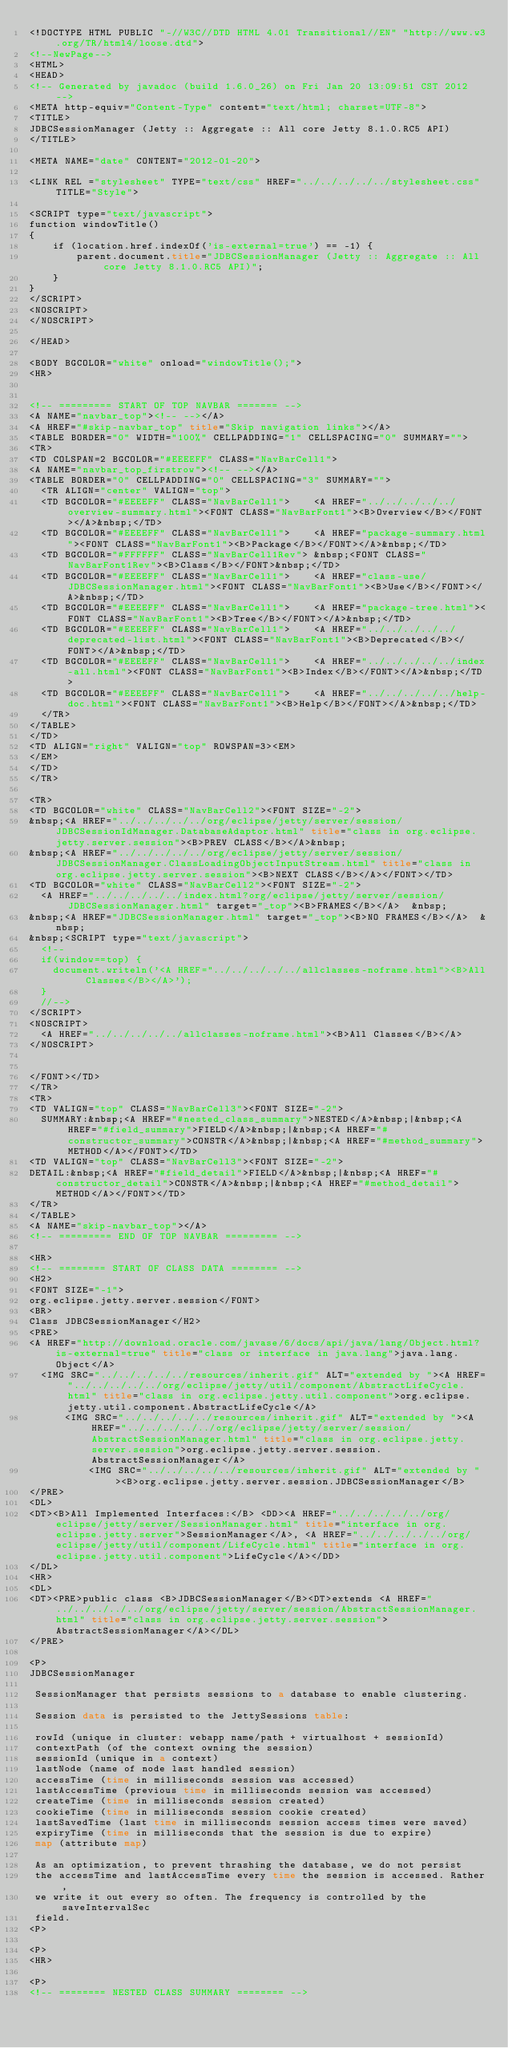<code> <loc_0><loc_0><loc_500><loc_500><_HTML_><!DOCTYPE HTML PUBLIC "-//W3C//DTD HTML 4.01 Transitional//EN" "http://www.w3.org/TR/html4/loose.dtd">
<!--NewPage-->
<HTML>
<HEAD>
<!-- Generated by javadoc (build 1.6.0_26) on Fri Jan 20 13:09:51 CST 2012 -->
<META http-equiv="Content-Type" content="text/html; charset=UTF-8">
<TITLE>
JDBCSessionManager (Jetty :: Aggregate :: All core Jetty 8.1.0.RC5 API)
</TITLE>

<META NAME="date" CONTENT="2012-01-20">

<LINK REL ="stylesheet" TYPE="text/css" HREF="../../../../../stylesheet.css" TITLE="Style">

<SCRIPT type="text/javascript">
function windowTitle()
{
    if (location.href.indexOf('is-external=true') == -1) {
        parent.document.title="JDBCSessionManager (Jetty :: Aggregate :: All core Jetty 8.1.0.RC5 API)";
    }
}
</SCRIPT>
<NOSCRIPT>
</NOSCRIPT>

</HEAD>

<BODY BGCOLOR="white" onload="windowTitle();">
<HR>


<!-- ========= START OF TOP NAVBAR ======= -->
<A NAME="navbar_top"><!-- --></A>
<A HREF="#skip-navbar_top" title="Skip navigation links"></A>
<TABLE BORDER="0" WIDTH="100%" CELLPADDING="1" CELLSPACING="0" SUMMARY="">
<TR>
<TD COLSPAN=2 BGCOLOR="#EEEEFF" CLASS="NavBarCell1">
<A NAME="navbar_top_firstrow"><!-- --></A>
<TABLE BORDER="0" CELLPADDING="0" CELLSPACING="3" SUMMARY="">
  <TR ALIGN="center" VALIGN="top">
  <TD BGCOLOR="#EEEEFF" CLASS="NavBarCell1">    <A HREF="../../../../../overview-summary.html"><FONT CLASS="NavBarFont1"><B>Overview</B></FONT></A>&nbsp;</TD>
  <TD BGCOLOR="#EEEEFF" CLASS="NavBarCell1">    <A HREF="package-summary.html"><FONT CLASS="NavBarFont1"><B>Package</B></FONT></A>&nbsp;</TD>
  <TD BGCOLOR="#FFFFFF" CLASS="NavBarCell1Rev"> &nbsp;<FONT CLASS="NavBarFont1Rev"><B>Class</B></FONT>&nbsp;</TD>
  <TD BGCOLOR="#EEEEFF" CLASS="NavBarCell1">    <A HREF="class-use/JDBCSessionManager.html"><FONT CLASS="NavBarFont1"><B>Use</B></FONT></A>&nbsp;</TD>
  <TD BGCOLOR="#EEEEFF" CLASS="NavBarCell1">    <A HREF="package-tree.html"><FONT CLASS="NavBarFont1"><B>Tree</B></FONT></A>&nbsp;</TD>
  <TD BGCOLOR="#EEEEFF" CLASS="NavBarCell1">    <A HREF="../../../../../deprecated-list.html"><FONT CLASS="NavBarFont1"><B>Deprecated</B></FONT></A>&nbsp;</TD>
  <TD BGCOLOR="#EEEEFF" CLASS="NavBarCell1">    <A HREF="../../../../../index-all.html"><FONT CLASS="NavBarFont1"><B>Index</B></FONT></A>&nbsp;</TD>
  <TD BGCOLOR="#EEEEFF" CLASS="NavBarCell1">    <A HREF="../../../../../help-doc.html"><FONT CLASS="NavBarFont1"><B>Help</B></FONT></A>&nbsp;</TD>
  </TR>
</TABLE>
</TD>
<TD ALIGN="right" VALIGN="top" ROWSPAN=3><EM>
</EM>
</TD>
</TR>

<TR>
<TD BGCOLOR="white" CLASS="NavBarCell2"><FONT SIZE="-2">
&nbsp;<A HREF="../../../../../org/eclipse/jetty/server/session/JDBCSessionIdManager.DatabaseAdaptor.html" title="class in org.eclipse.jetty.server.session"><B>PREV CLASS</B></A>&nbsp;
&nbsp;<A HREF="../../../../../org/eclipse/jetty/server/session/JDBCSessionManager.ClassLoadingObjectInputStream.html" title="class in org.eclipse.jetty.server.session"><B>NEXT CLASS</B></A></FONT></TD>
<TD BGCOLOR="white" CLASS="NavBarCell2"><FONT SIZE="-2">
  <A HREF="../../../../../index.html?org/eclipse/jetty/server/session/JDBCSessionManager.html" target="_top"><B>FRAMES</B></A>  &nbsp;
&nbsp;<A HREF="JDBCSessionManager.html" target="_top"><B>NO FRAMES</B></A>  &nbsp;
&nbsp;<SCRIPT type="text/javascript">
  <!--
  if(window==top) {
    document.writeln('<A HREF="../../../../../allclasses-noframe.html"><B>All Classes</B></A>');
  }
  //-->
</SCRIPT>
<NOSCRIPT>
  <A HREF="../../../../../allclasses-noframe.html"><B>All Classes</B></A>
</NOSCRIPT>


</FONT></TD>
</TR>
<TR>
<TD VALIGN="top" CLASS="NavBarCell3"><FONT SIZE="-2">
  SUMMARY:&nbsp;<A HREF="#nested_class_summary">NESTED</A>&nbsp;|&nbsp;<A HREF="#field_summary">FIELD</A>&nbsp;|&nbsp;<A HREF="#constructor_summary">CONSTR</A>&nbsp;|&nbsp;<A HREF="#method_summary">METHOD</A></FONT></TD>
<TD VALIGN="top" CLASS="NavBarCell3"><FONT SIZE="-2">
DETAIL:&nbsp;<A HREF="#field_detail">FIELD</A>&nbsp;|&nbsp;<A HREF="#constructor_detail">CONSTR</A>&nbsp;|&nbsp;<A HREF="#method_detail">METHOD</A></FONT></TD>
</TR>
</TABLE>
<A NAME="skip-navbar_top"></A>
<!-- ========= END OF TOP NAVBAR ========= -->

<HR>
<!-- ======== START OF CLASS DATA ======== -->
<H2>
<FONT SIZE="-1">
org.eclipse.jetty.server.session</FONT>
<BR>
Class JDBCSessionManager</H2>
<PRE>
<A HREF="http://download.oracle.com/javase/6/docs/api/java/lang/Object.html?is-external=true" title="class or interface in java.lang">java.lang.Object</A>
  <IMG SRC="../../../../../resources/inherit.gif" ALT="extended by "><A HREF="../../../../../org/eclipse/jetty/util/component/AbstractLifeCycle.html" title="class in org.eclipse.jetty.util.component">org.eclipse.jetty.util.component.AbstractLifeCycle</A>
      <IMG SRC="../../../../../resources/inherit.gif" ALT="extended by "><A HREF="../../../../../org/eclipse/jetty/server/session/AbstractSessionManager.html" title="class in org.eclipse.jetty.server.session">org.eclipse.jetty.server.session.AbstractSessionManager</A>
          <IMG SRC="../../../../../resources/inherit.gif" ALT="extended by "><B>org.eclipse.jetty.server.session.JDBCSessionManager</B>
</PRE>
<DL>
<DT><B>All Implemented Interfaces:</B> <DD><A HREF="../../../../../org/eclipse/jetty/server/SessionManager.html" title="interface in org.eclipse.jetty.server">SessionManager</A>, <A HREF="../../../../../org/eclipse/jetty/util/component/LifeCycle.html" title="interface in org.eclipse.jetty.util.component">LifeCycle</A></DD>
</DL>
<HR>
<DL>
<DT><PRE>public class <B>JDBCSessionManager</B><DT>extends <A HREF="../../../../../org/eclipse/jetty/server/session/AbstractSessionManager.html" title="class in org.eclipse.jetty.server.session">AbstractSessionManager</A></DL>
</PRE>

<P>
JDBCSessionManager

 SessionManager that persists sessions to a database to enable clustering.

 Session data is persisted to the JettySessions table:

 rowId (unique in cluster: webapp name/path + virtualhost + sessionId)
 contextPath (of the context owning the session)
 sessionId (unique in a context)
 lastNode (name of node last handled session)
 accessTime (time in milliseconds session was accessed)
 lastAccessTime (previous time in milliseconds session was accessed)
 createTime (time in milliseconds session created)
 cookieTime (time in milliseconds session cookie created)
 lastSavedTime (last time in milliseconds session access times were saved)
 expiryTime (time in milliseconds that the session is due to expire)
 map (attribute map)

 As an optimization, to prevent thrashing the database, we do not persist
 the accessTime and lastAccessTime every time the session is accessed. Rather,
 we write it out every so often. The frequency is controlled by the saveIntervalSec
 field.
<P>

<P>
<HR>

<P>
<!-- ======== NESTED CLASS SUMMARY ======== -->
</code> 